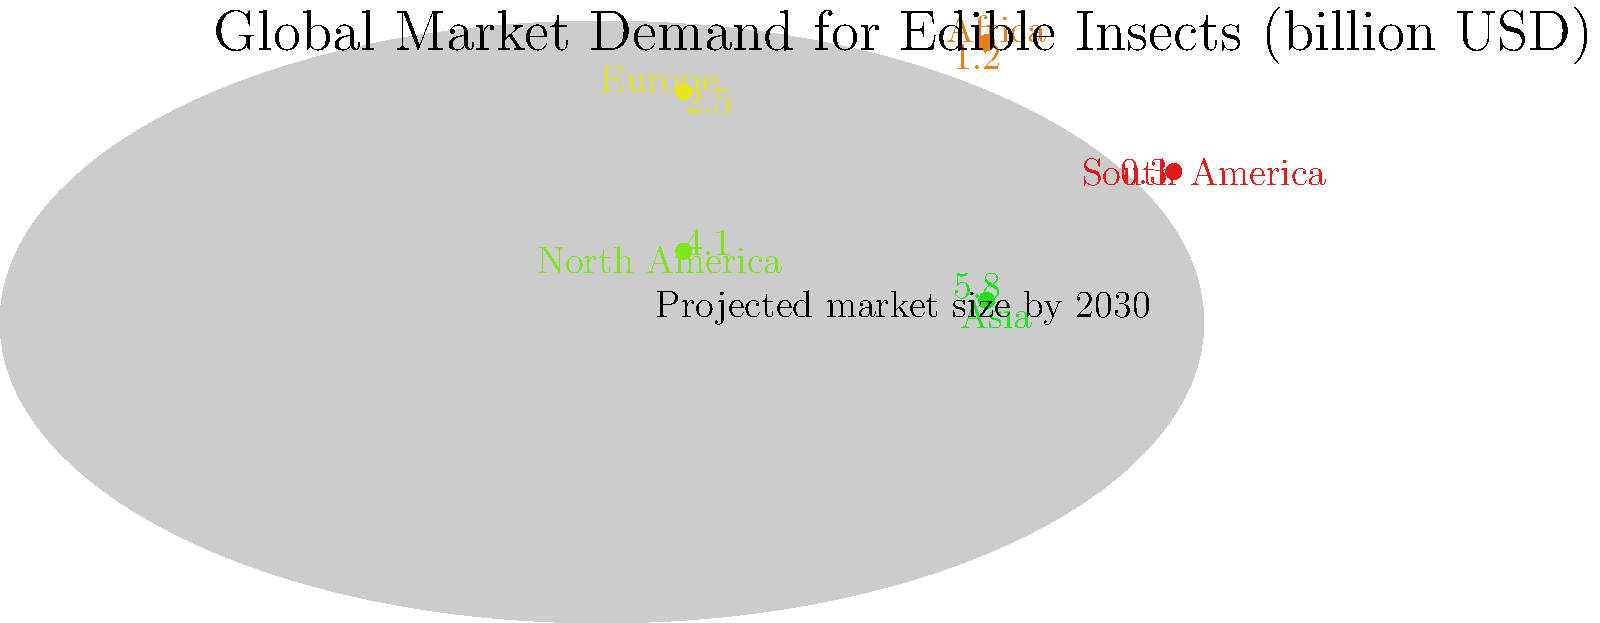Based on the world map showing projected market sizes for edible insects by 2030, which region is expected to have the highest demand, and what factors might contribute to this region's leadership in the edible insect market? To answer this question, we need to analyze the data presented in the world map:

1. Examine the projected market sizes for each region:
   - South America: $0.3 billion
   - Africa: $1.2 billion
   - Europe: $2.5 billion
   - North America: $4.1 billion
   - Asia: $5.8 billion

2. Identify the region with the highest projected market size:
   Asia has the highest value at $5.8 billion.

3. Consider factors contributing to Asia's leadership:
   a) Cultural acceptance: Many Asian countries have a long history of entomophagy (eating insects).
   b) Population size: Asia has the largest population, increasing potential market size.
   c) Protein demand: Growing middle class in Asia is increasing demand for alternative protein sources.
   d) Agricultural practices: Some Asian countries already incorporate insects in animal feed.
   e) Sustainability focus: Many Asian countries are adopting sustainable food practices to address food security.

4. Compare with other regions:
   North America shows the second-highest demand, possibly due to growing interest in sustainable protein sources and innovative food tech startups.

5. Consider global context:
   The total projected market size across all regions is approximately $13.9 billion, with Asia representing about 41.7% of the global market.
Answer: Asia, due to cultural acceptance, large population, increasing protein demand, existing agricultural practices, and sustainability focus. 